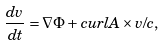Convert formula to latex. <formula><loc_0><loc_0><loc_500><loc_500>\frac { d { v } } { d t } = \nabla \Phi + c u r l { A } \times { v } / c ,</formula> 